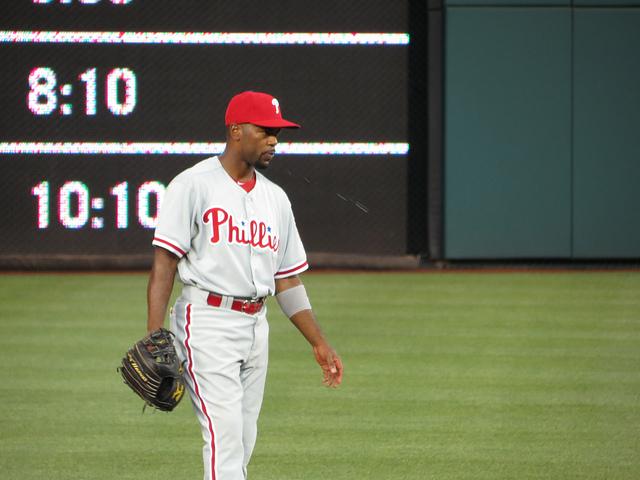What game is this man playing?
Keep it brief. Baseball. What is this man's ethnicity?
Write a very short answer. Black. What team does the player play for?
Give a very brief answer. Phillies. What team does the man play for?
Answer briefly. Phillies. 